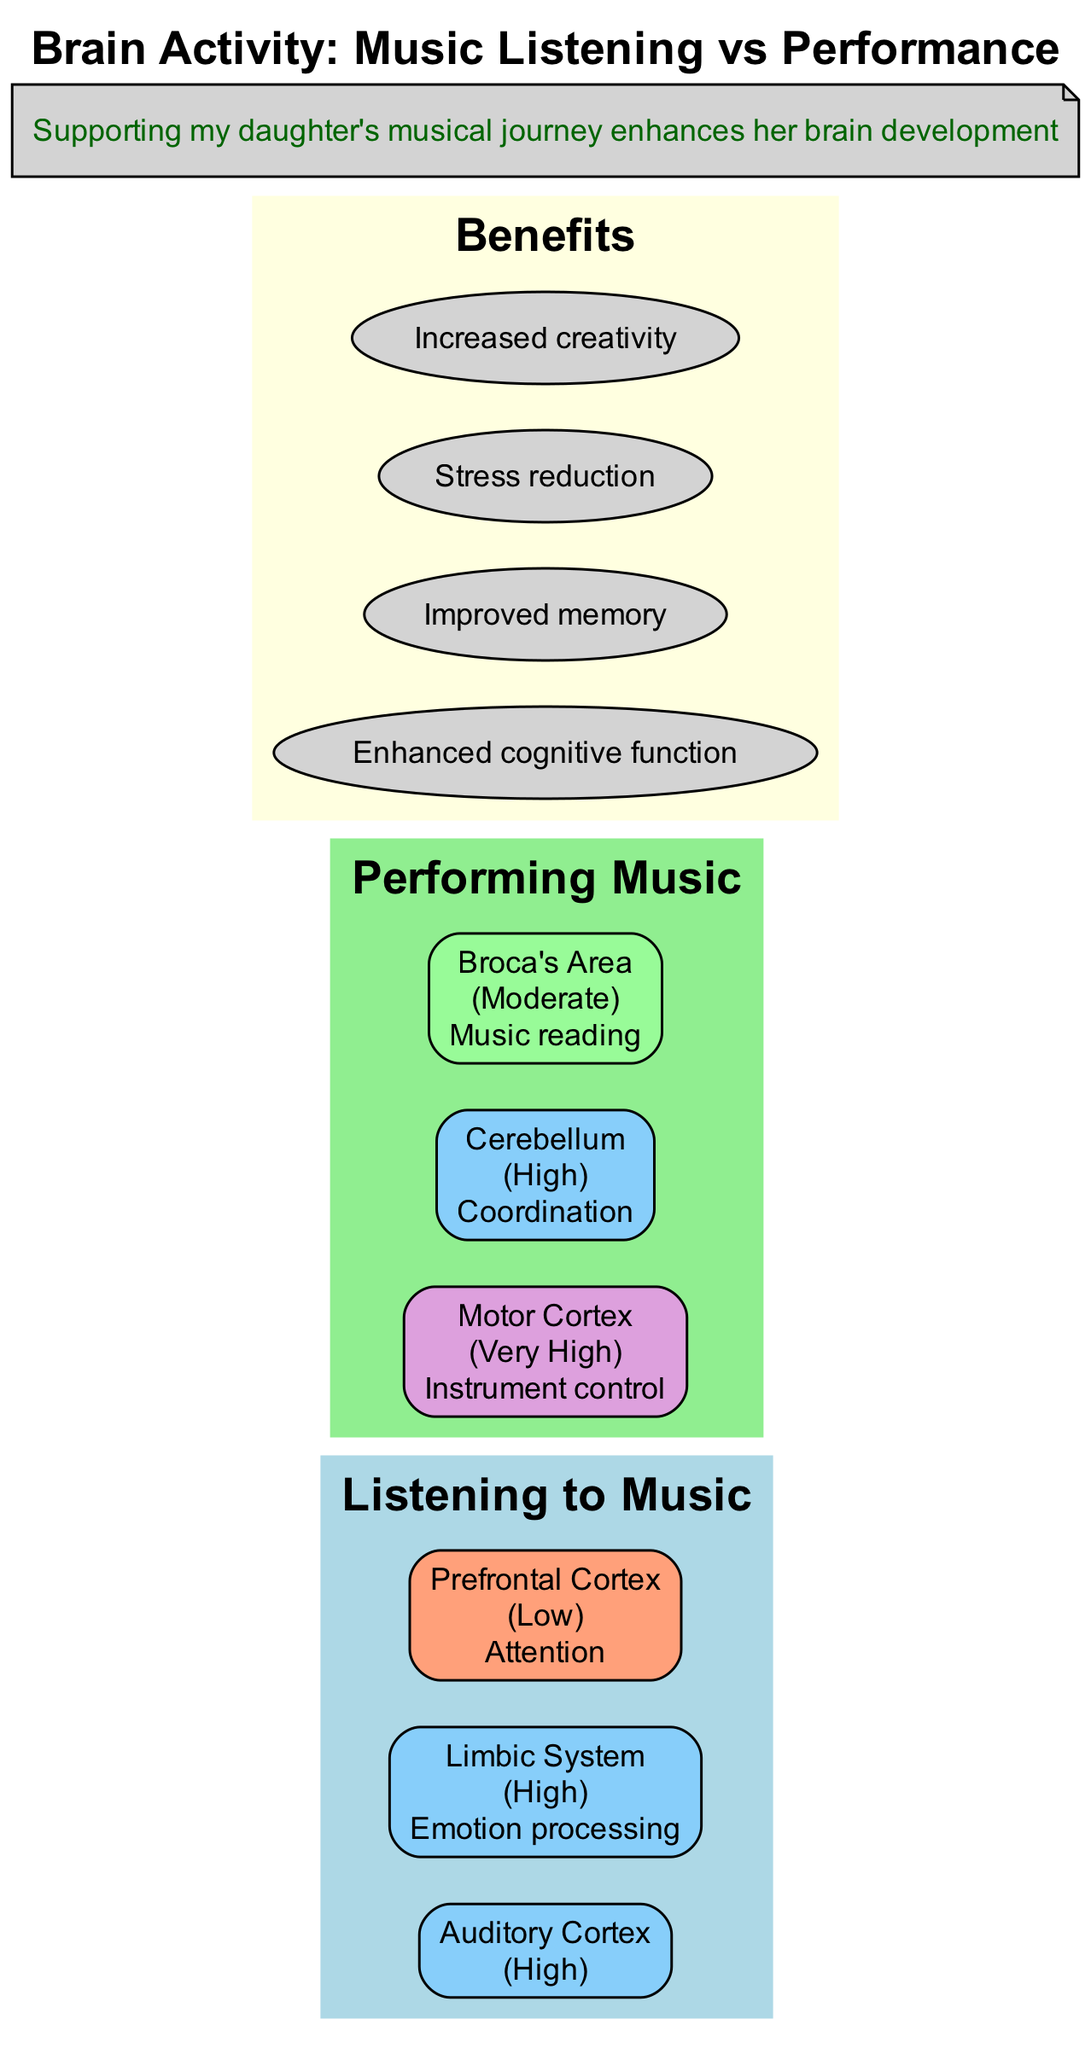What is the activity level in the Auditory Cortex during music listening? The diagram indicates that the activity level in the Auditory Cortex during music listening is categorized as "Moderate."
Answer: Moderate Which music engagement has a "Very High" activity in the Motor Cortex? The diagram shows that performing music is associated with "Very High" activity in the Motor Cortex.
Answer: Performing Music How many regions are activated during the "Listening to Music" section? The diagram lists three regions under "Listening to Music" which are the Auditory Cortex, Limbic System, and Prefrontal Cortex.
Answer: Three What type of processing is associated with "High" activity in the Limbic System? The diagram notes that the "High" activity in the Limbic System is associated with "Emotion processing."
Answer: Emotion processing What is the benefit of musical engagement related to stress? The diagram specifically mentions "Stress reduction" as one of the benefits of musical engagement.
Answer: Stress reduction Which area has "Moderate" activity during music performance? According to the diagram, Broca's Area has "Moderate" activity during music performance.
Answer: Broca's Area Which two music activities engage the Auditory Cortex? The diagram states that both "Listening to Music" and "Performing Music" engage the Auditory Cortex, with different activity levels.
Answer: Listening to Music and Performing Music What is the note for "Very High" activity in the Motor Cortex? The diagram indicates that the "Very High" activity in the Motor Cortex is related to "Instrument control."
Answer: Instrument control 